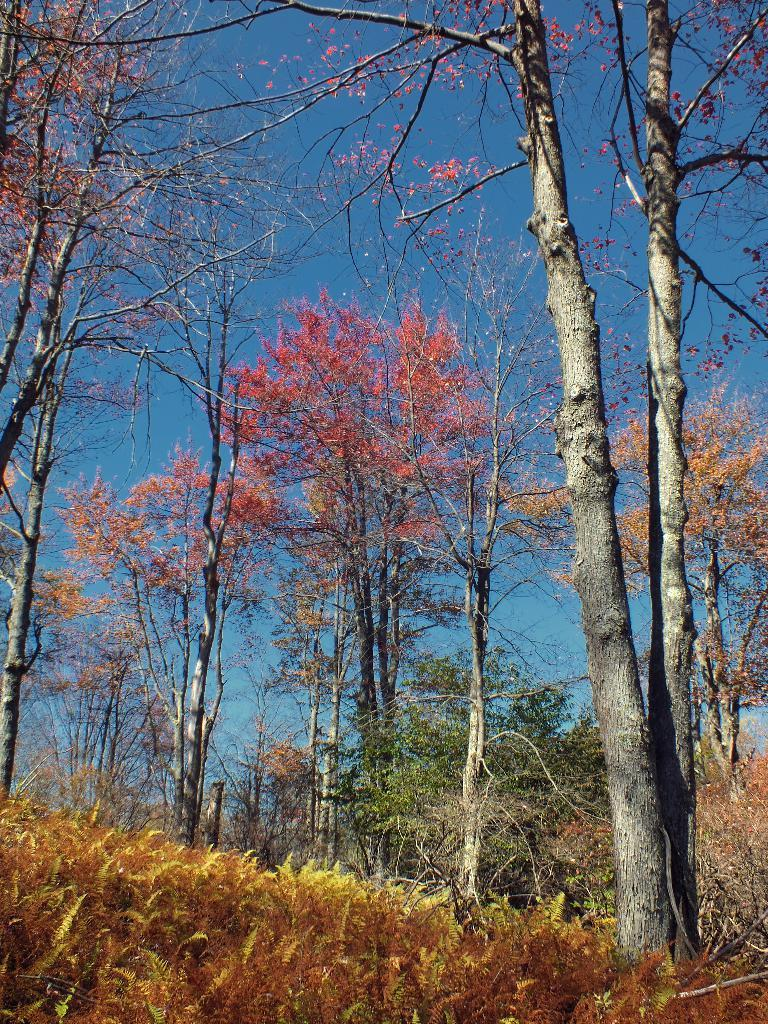What type of vegetation can be seen in the image? There are trees in the image. What is visible at the top of the image? The sky is visible at the top of the image. Can you see the governor in the image? There is no governor present in the image. Are there any fairies visible in the image? There are no fairies present in the image. 